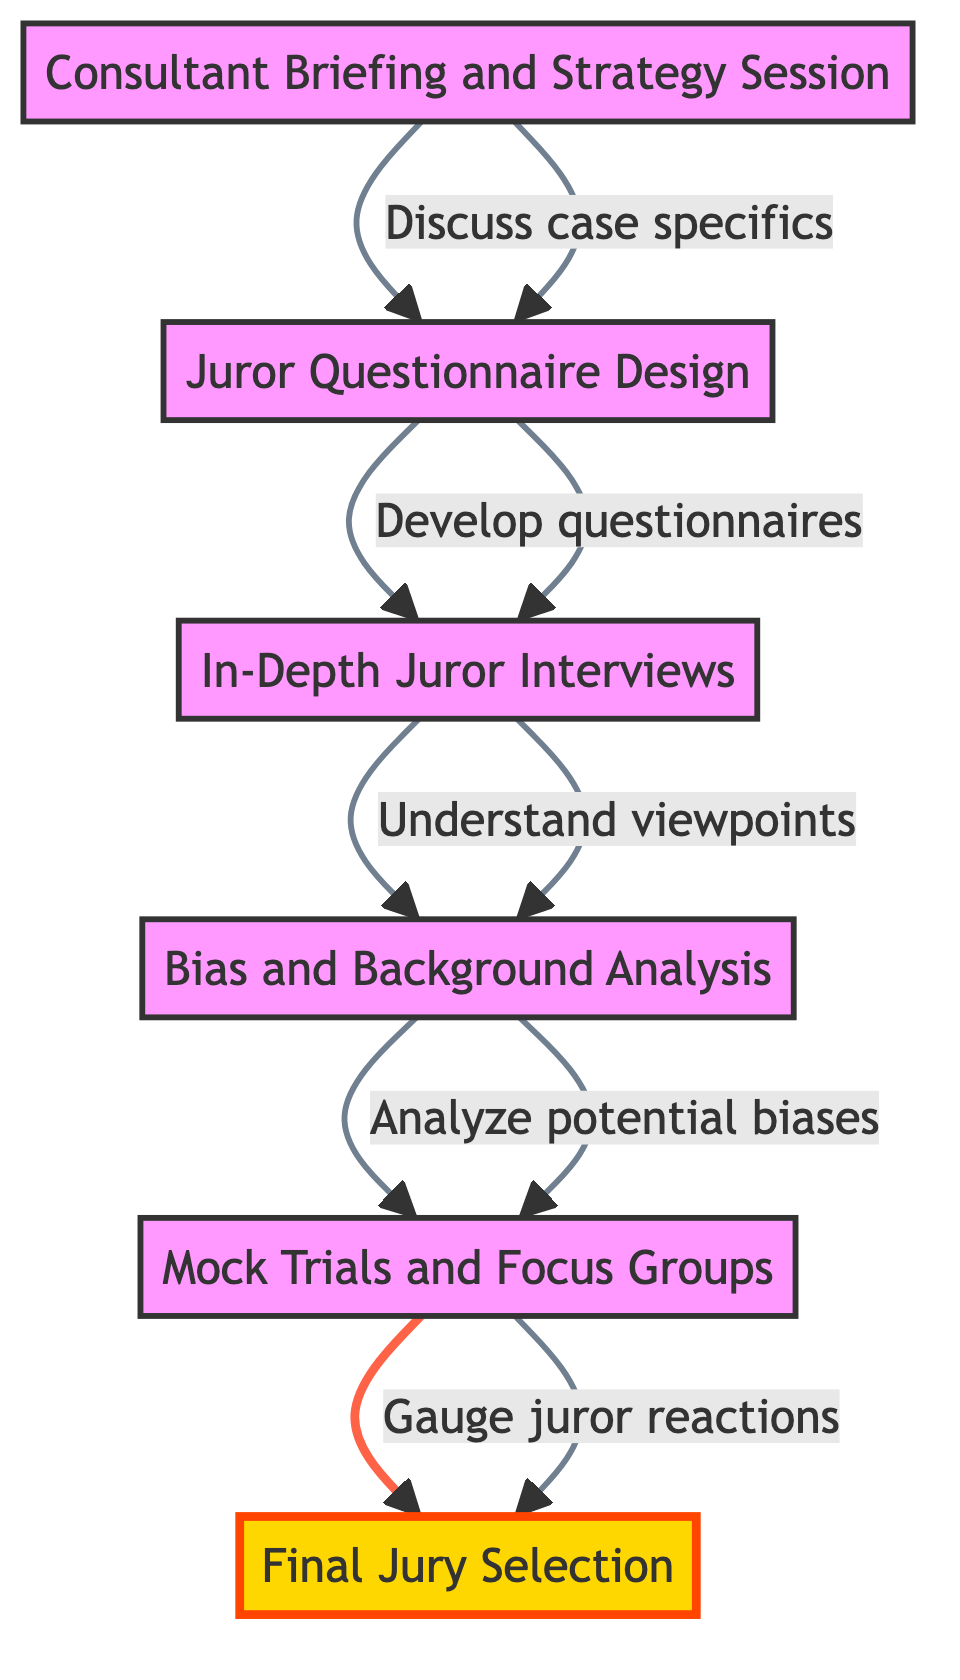What is the first step in the process? The first step in the diagram is the "Consultant Briefing and Strategy Session," indicating it is where the jury selection process begins.
Answer: Consultant Briefing and Strategy Session How many steps are in the flowchart? The flowchart contains six steps, as indicated by the six distinct nodes connected by arrows.
Answer: 6 What follows the "Bias and Background Analysis"? Following the "Bias and Background Analysis," the next step is the "Mock Trials and Focus Groups," showing the flow from one process to the next.
Answer: Mock Trials and Focus Groups What is the final step displayed in the diagram? The final step seen in the diagram is "Final Jury Selection," which emphasizes the culmination of the jury selection process.
Answer: Final Jury Selection Which step comes before "In-Depth Juror Interviews"? The step before "In-Depth Juror Interviews" is "Juror Questionnaire Design," which is essential for gathering the needed information from potential jurors.
Answer: Juror Questionnaire Design What relationship exists between "Consultant Briefing and Strategy Session" and "Juror Questionnaire Design"? The relationship is that the "Consultant Briefing and Strategy Session" leads directly to the "Juror Questionnaire Design," indicating that the discussion lays the groundwork for developing questionnaires.
Answer: Discuss case specifics What does "Mock Trials and Focus Groups" aim to achieve? "Mock Trials and Focus Groups" aim to gauge juror reactions and collect feedback, showing their importance in understanding juror responses.
Answer: Gauge juror reactions How do potential jurors' biases get analyzed? Potential jurors' biases are analyzed through the "Bias and Background Analysis" step using tools such as social media and background checks.
Answer: Social media, background checks What is the primary purpose of the flowchart? The primary purpose of the flowchart is to illustrate the process of consulting jury consultants to optimize juror selection for favorable biases.
Answer: Optimize juror selection 